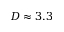Convert formula to latex. <formula><loc_0><loc_0><loc_500><loc_500>D \approx 3 . 3</formula> 